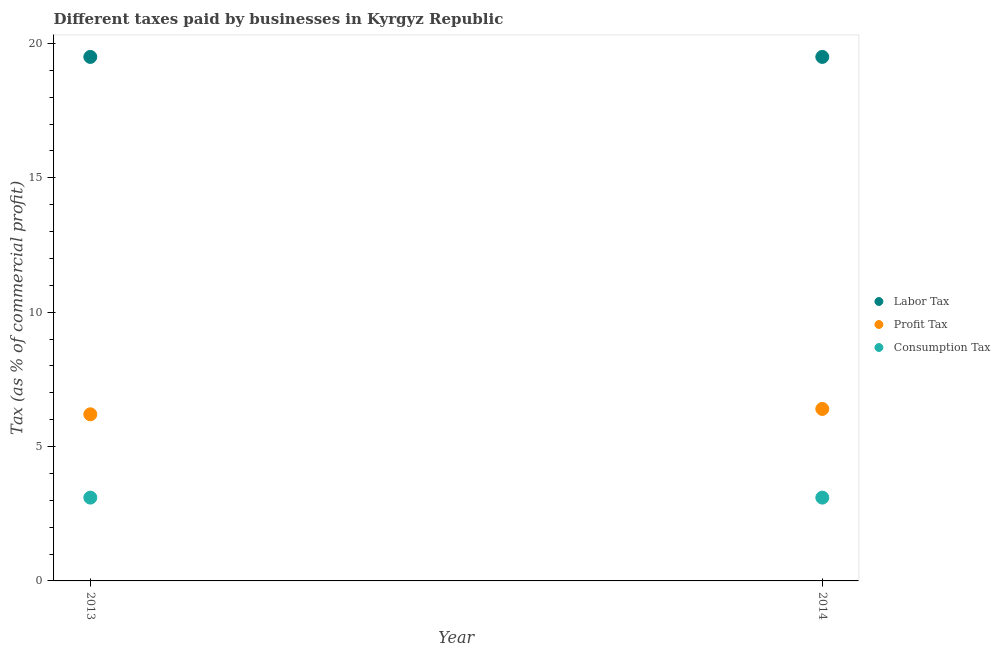How many different coloured dotlines are there?
Provide a succinct answer. 3. Is the number of dotlines equal to the number of legend labels?
Keep it short and to the point. Yes. What is the percentage of profit tax in 2013?
Keep it short and to the point. 6.2. Across all years, what is the minimum percentage of profit tax?
Ensure brevity in your answer.  6.2. In which year was the percentage of profit tax minimum?
Your response must be concise. 2013. What is the total percentage of labor tax in the graph?
Give a very brief answer. 39. In the year 2014, what is the difference between the percentage of consumption tax and percentage of labor tax?
Keep it short and to the point. -16.4. In how many years, is the percentage of consumption tax greater than 8 %?
Your response must be concise. 0. What is the ratio of the percentage of profit tax in 2013 to that in 2014?
Make the answer very short. 0.97. Does the percentage of consumption tax monotonically increase over the years?
Keep it short and to the point. No. Is the percentage of consumption tax strictly greater than the percentage of labor tax over the years?
Your answer should be compact. No. Is the percentage of profit tax strictly less than the percentage of labor tax over the years?
Your answer should be compact. Yes. How many years are there in the graph?
Give a very brief answer. 2. What is the difference between two consecutive major ticks on the Y-axis?
Provide a short and direct response. 5. Are the values on the major ticks of Y-axis written in scientific E-notation?
Provide a succinct answer. No. Does the graph contain any zero values?
Keep it short and to the point. No. What is the title of the graph?
Provide a short and direct response. Different taxes paid by businesses in Kyrgyz Republic. Does "Argument" appear as one of the legend labels in the graph?
Ensure brevity in your answer.  No. What is the label or title of the X-axis?
Make the answer very short. Year. What is the label or title of the Y-axis?
Give a very brief answer. Tax (as % of commercial profit). What is the Tax (as % of commercial profit) in Consumption Tax in 2013?
Provide a short and direct response. 3.1. What is the Tax (as % of commercial profit) of Labor Tax in 2014?
Offer a very short reply. 19.5. What is the Tax (as % of commercial profit) of Profit Tax in 2014?
Make the answer very short. 6.4. Across all years, what is the maximum Tax (as % of commercial profit) of Consumption Tax?
Your response must be concise. 3.1. What is the total Tax (as % of commercial profit) of Labor Tax in the graph?
Keep it short and to the point. 39. What is the difference between the Tax (as % of commercial profit) in Profit Tax in 2013 and that in 2014?
Provide a succinct answer. -0.2. What is the difference between the Tax (as % of commercial profit) in Labor Tax in 2013 and the Tax (as % of commercial profit) in Profit Tax in 2014?
Offer a very short reply. 13.1. What is the difference between the Tax (as % of commercial profit) of Labor Tax in 2013 and the Tax (as % of commercial profit) of Consumption Tax in 2014?
Your answer should be compact. 16.4. What is the average Tax (as % of commercial profit) in Labor Tax per year?
Make the answer very short. 19.5. What is the average Tax (as % of commercial profit) in Consumption Tax per year?
Offer a terse response. 3.1. In the year 2014, what is the difference between the Tax (as % of commercial profit) of Labor Tax and Tax (as % of commercial profit) of Consumption Tax?
Ensure brevity in your answer.  16.4. What is the ratio of the Tax (as % of commercial profit) in Labor Tax in 2013 to that in 2014?
Your answer should be compact. 1. What is the ratio of the Tax (as % of commercial profit) of Profit Tax in 2013 to that in 2014?
Your response must be concise. 0.97. What is the ratio of the Tax (as % of commercial profit) in Consumption Tax in 2013 to that in 2014?
Make the answer very short. 1. What is the difference between the highest and the second highest Tax (as % of commercial profit) in Labor Tax?
Your answer should be compact. 0. What is the difference between the highest and the second highest Tax (as % of commercial profit) in Consumption Tax?
Your response must be concise. 0. What is the difference between the highest and the lowest Tax (as % of commercial profit) in Consumption Tax?
Ensure brevity in your answer.  0. 